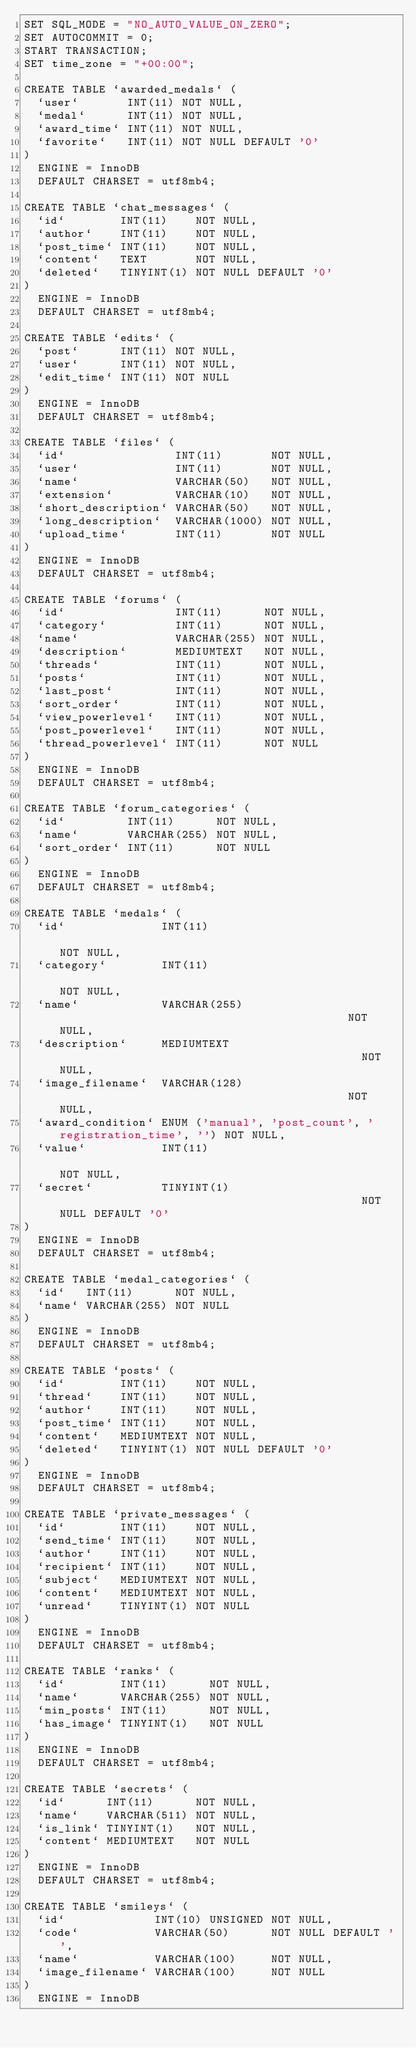<code> <loc_0><loc_0><loc_500><loc_500><_SQL_>SET SQL_MODE = "NO_AUTO_VALUE_ON_ZERO";
SET AUTOCOMMIT = 0;
START TRANSACTION;
SET time_zone = "+00:00";

CREATE TABLE `awarded_medals` (
  `user`       INT(11) NOT NULL,
  `medal`      INT(11) NOT NULL,
  `award_time` INT(11) NOT NULL,
  `favorite`   INT(11) NOT NULL DEFAULT '0'
)
  ENGINE = InnoDB
  DEFAULT CHARSET = utf8mb4;

CREATE TABLE `chat_messages` (
  `id`        INT(11)    NOT NULL,
  `author`    INT(11)    NOT NULL,
  `post_time` INT(11)    NOT NULL,
  `content`   TEXT       NOT NULL,
  `deleted`   TINYINT(1) NOT NULL DEFAULT '0'
)
  ENGINE = InnoDB
  DEFAULT CHARSET = utf8mb4;

CREATE TABLE `edits` (
  `post`      INT(11) NOT NULL,
  `user`      INT(11) NOT NULL,
  `edit_time` INT(11) NOT NULL
)
  ENGINE = InnoDB
  DEFAULT CHARSET = utf8mb4;

CREATE TABLE `files` (
  `id`                INT(11)       NOT NULL,
  `user`              INT(11)       NOT NULL,
  `name`              VARCHAR(50)   NOT NULL,
  `extension`         VARCHAR(10)   NOT NULL,
  `short_description` VARCHAR(50)   NOT NULL,
  `long_description`  VARCHAR(1000) NOT NULL,
  `upload_time`       INT(11)       NOT NULL
)
  ENGINE = InnoDB
  DEFAULT CHARSET = utf8mb4;

CREATE TABLE `forums` (
  `id`                INT(11)      NOT NULL,
  `category`          INT(11)      NOT NULL,
  `name`              VARCHAR(255) NOT NULL,
  `description`       MEDIUMTEXT   NOT NULL,
  `threads`           INT(11)      NOT NULL,
  `posts`             INT(11)      NOT NULL,
  `last_post`         INT(11)      NOT NULL,
  `sort_order`        INT(11)      NOT NULL,
  `view_powerlevel`   INT(11)      NOT NULL,
  `post_powerlevel`   INT(11)      NOT NULL,
  `thread_powerlevel` INT(11)      NOT NULL
)
  ENGINE = InnoDB
  DEFAULT CHARSET = utf8mb4;

CREATE TABLE `forum_categories` (
  `id`         INT(11)      NOT NULL,
  `name`       VARCHAR(255) NOT NULL,
  `sort_order` INT(11)      NOT NULL
)
  ENGINE = InnoDB
  DEFAULT CHARSET = utf8mb4;

CREATE TABLE `medals` (
  `id`              INT(11)                                                NOT NULL,
  `category`        INT(11)                                                NOT NULL,
  `name`            VARCHAR(255)                                           NOT NULL,
  `description`     MEDIUMTEXT                                             NOT NULL,
  `image_filename`  VARCHAR(128)                                           NOT NULL,
  `award_condition` ENUM ('manual', 'post_count', 'registration_time', '') NOT NULL,
  `value`           INT(11)                                                NOT NULL,
  `secret`          TINYINT(1)                                             NOT NULL DEFAULT '0'
)
  ENGINE = InnoDB
  DEFAULT CHARSET = utf8mb4;

CREATE TABLE `medal_categories` (
  `id`   INT(11)      NOT NULL,
  `name` VARCHAR(255) NOT NULL
)
  ENGINE = InnoDB
  DEFAULT CHARSET = utf8mb4;

CREATE TABLE `posts` (
  `id`        INT(11)    NOT NULL,
  `thread`    INT(11)    NOT NULL,
  `author`    INT(11)    NOT NULL,
  `post_time` INT(11)    NOT NULL,
  `content`   MEDIUMTEXT NOT NULL,
  `deleted`   TINYINT(1) NOT NULL DEFAULT '0'
)
  ENGINE = InnoDB
  DEFAULT CHARSET = utf8mb4;

CREATE TABLE `private_messages` (
  `id`        INT(11)    NOT NULL,
  `send_time` INT(11)    NOT NULL,
  `author`    INT(11)    NOT NULL,
  `recipient` INT(11)    NOT NULL,
  `subject`   MEDIUMTEXT NOT NULL,
  `content`   MEDIUMTEXT NOT NULL,
  `unread`    TINYINT(1) NOT NULL
)
  ENGINE = InnoDB
  DEFAULT CHARSET = utf8mb4;

CREATE TABLE `ranks` (
  `id`        INT(11)      NOT NULL,
  `name`      VARCHAR(255) NOT NULL,
  `min_posts` INT(11)      NOT NULL,
  `has_image` TINYINT(1)   NOT NULL
)
  ENGINE = InnoDB
  DEFAULT CHARSET = utf8mb4;

CREATE TABLE `secrets` (
  `id`      INT(11)      NOT NULL,
  `name`    VARCHAR(511) NOT NULL,
  `is_link` TINYINT(1)   NOT NULL,
  `content` MEDIUMTEXT   NOT NULL
)
  ENGINE = InnoDB
  DEFAULT CHARSET = utf8mb4;

CREATE TABLE `smileys` (
  `id`             INT(10) UNSIGNED NOT NULL,
  `code`           VARCHAR(50)      NOT NULL DEFAULT '',
  `name`           VARCHAR(100)     NOT NULL,
  `image_filename` VARCHAR(100)     NOT NULL
)
  ENGINE = InnoDB</code> 